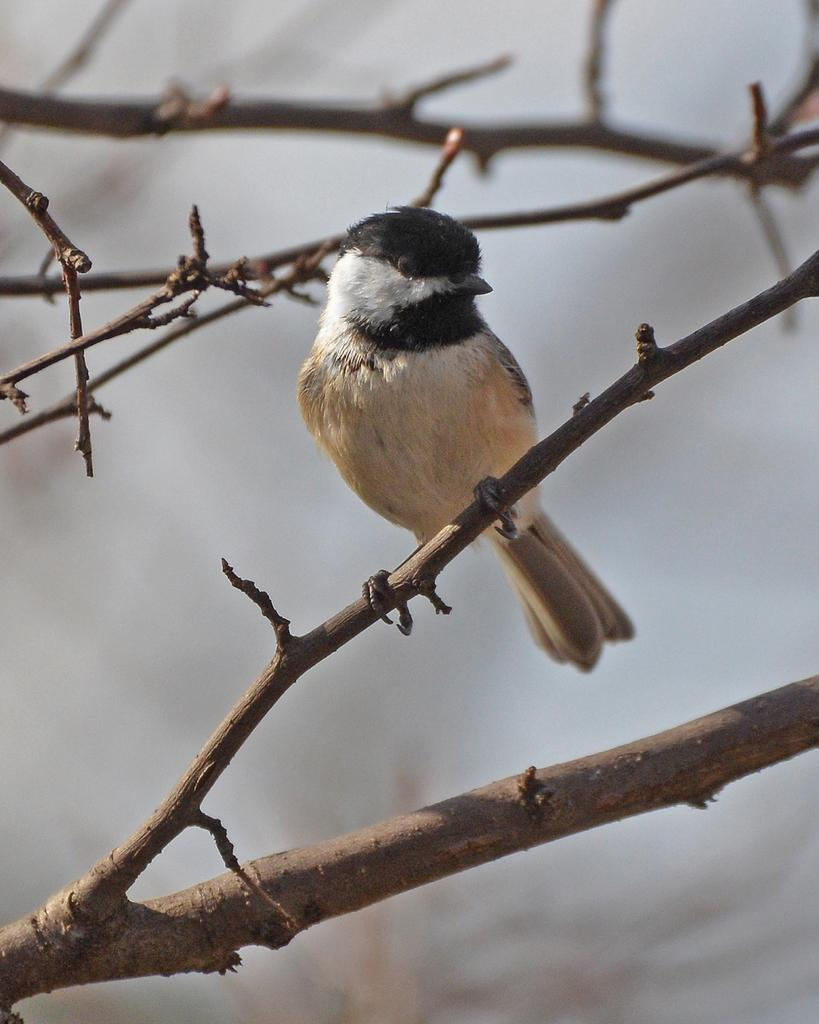What is the main subject in the center of the image? There are branches in the center of the image. Is there any living creature on the branches? Yes, there is a bird on one of the branches. What can be said about the color of the bird? The bird is in black and white color. How would you describe the background of the image? The background of the image is blurred. Who is the manager of the bird in the image? There is no manager present in the image, as it features a bird on a branch. 